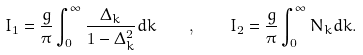<formula> <loc_0><loc_0><loc_500><loc_500>I _ { 1 } = \frac { g } { \pi } \int _ { 0 } ^ { \infty } \frac { \Delta _ { k } } { 1 - \Delta _ { k } ^ { 2 } } d k \quad , \quad I _ { 2 } = \frac { g } { \pi } \int _ { 0 } ^ { \infty } N _ { k } d k .</formula> 